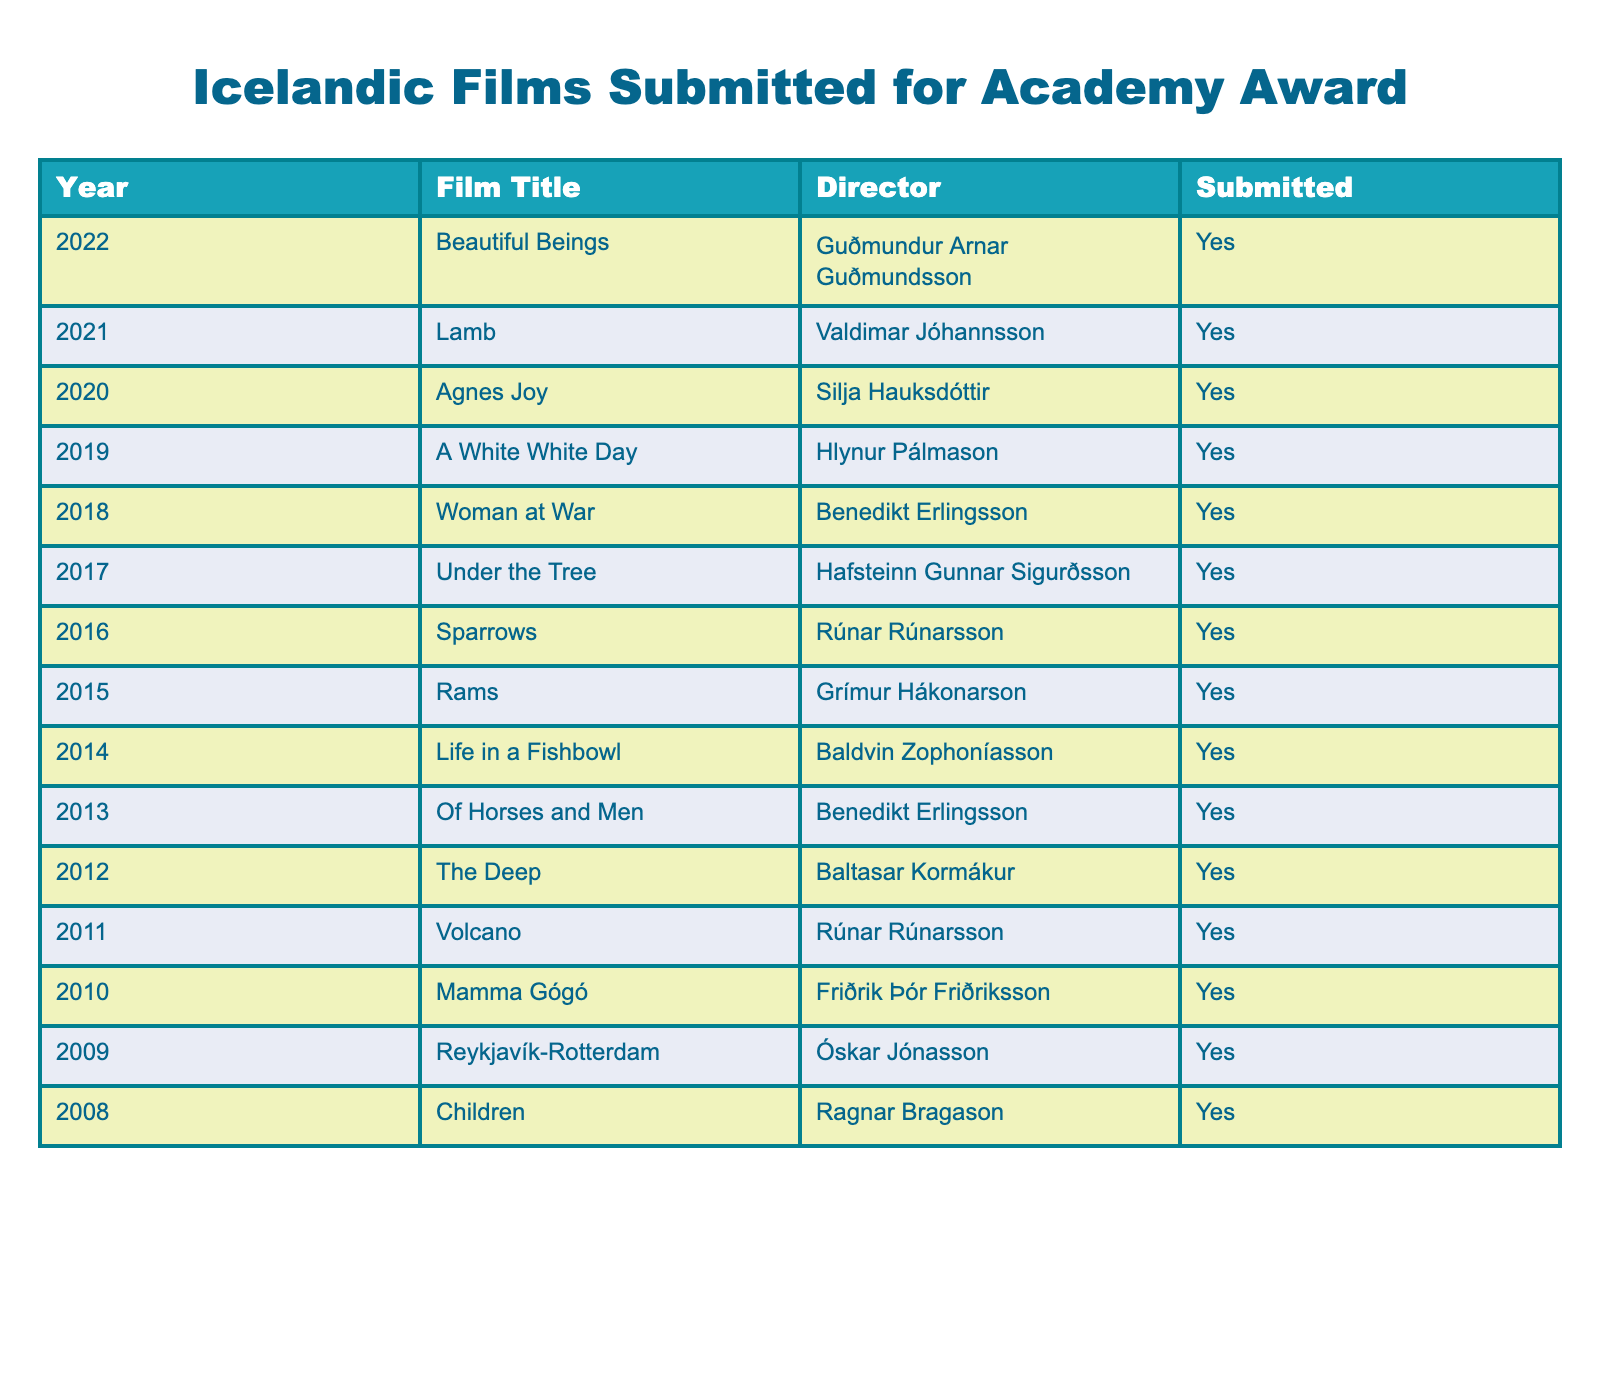What is the title of the film submitted in 2022? In the table, I look for the row where the year is 2022. The film title in that row is "Beautiful Beings."
Answer: Beautiful Beings Which film was submitted in 2011? To find the answer, I check the row for the year 2011, where I see that the film is titled "Volcano."
Answer: Volcano How many films were submitted between 2010 and 2015 inclusive? I count the rows for the years from 2010 to 2015, which gives me films for the years: 2010 (1), 2011 (1), 2012 (1), 2013 (1), 2014 (1), and 2015 (1). The total is 6 films.
Answer: 6 Who directed "Rams"? In the table, I locate the row for the film "Rams." The directed by field in that row indicates Grímur Hákonarson.
Answer: Grímur Hákonarson Was "Woman at War" submitted for the Academy Award? I check the row for the film "Woman at War," and it shows "Yes" in the submitted column, which confirms its submission.
Answer: Yes How many years did Iceland submit films from 2008 to 2012? I count the years from 2008 to 2012 inclusive, which are: 2008, 2009, 2010, 2011, and 2012, totaling 5 years.
Answer: 5 Which director submitted the most films between 2010 and 2022? Looking at the table and checking the directors: Rúnar Rúnarsson appears for "Mamma Gógó" (2010), "Volcano" (2011), and "Sparrows" (2016) for a total of 3 films, while others have fewer. Rúnar Rúnarsson directed the most films between that range.
Answer: Rúnar Rúnarsson In which year was the least recent film submitted? I examine the years in the table and see that 2008 is the earliest, with "Children" submitted that year.
Answer: 2008 How many films are submitted in total? I count all the rows in the table which indicate that a film was submitted. There are 15 rows, thus 15 films were submitted in total.
Answer: 15 Which year had the most recently submitted film? The most recent year listed in the table is 2022. The film submitted that year is "Beautiful Beings."
Answer: 2022 Is "Agnes Joy" the only film directed by Silja Hauksdóttir? I check the table, and I see that "Agnes Joy" is the only entry for Silja Hauksdóttir, confirming this to be true.
Answer: Yes 